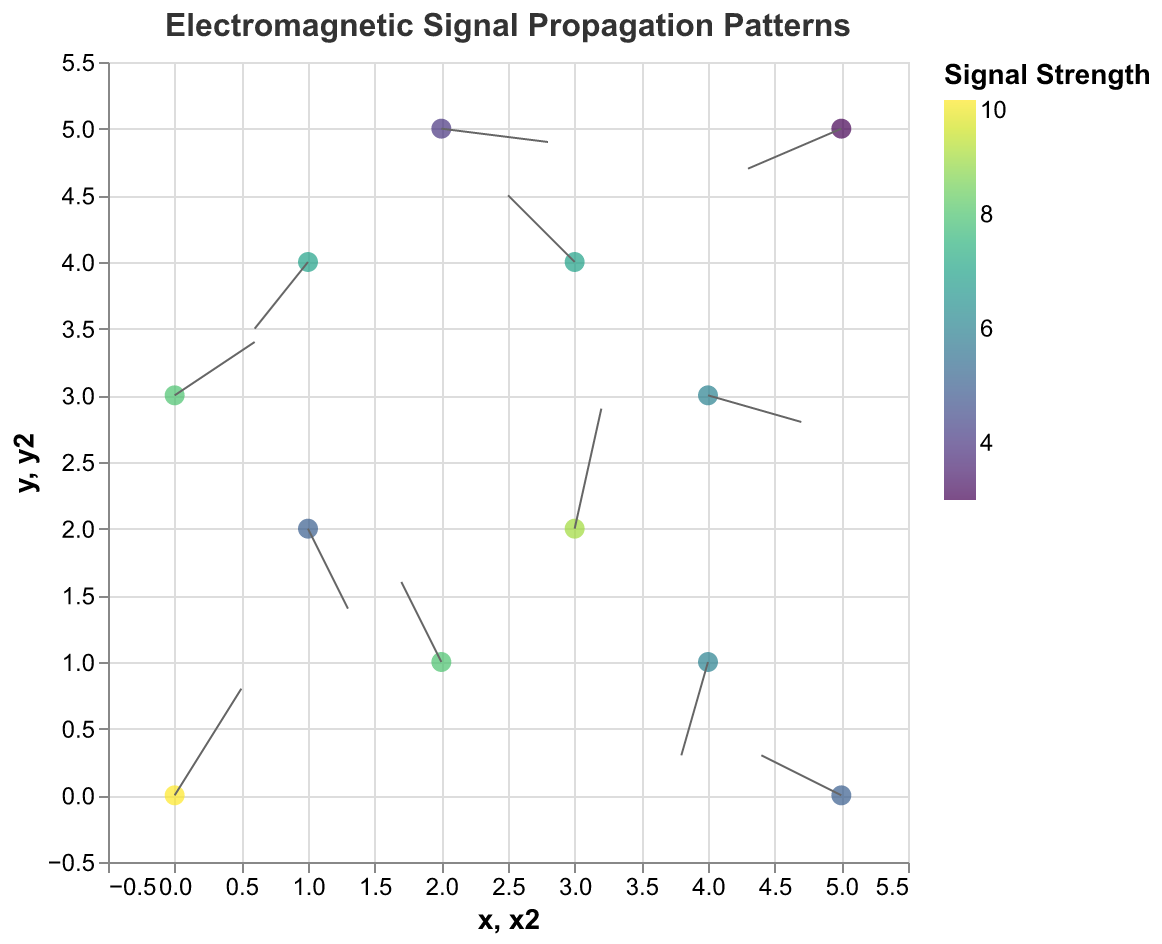What is the title of the figure? The title of the figure is usually displayed at the top and is used to summarize the main topic or purpose of the visualization. In this case, the title is clearly indicated in the JSON structure under "title" with the text "Electromagnetic Signal Propagation Patterns".
Answer: Electromagnetic Signal Propagation Patterns What are the axes ranges in the plot? The x and y axes ranges are specified in the JSON structure under the "scale" domain for both axes. For the x-axis, the range is from -0.5 to 5.5, and for the y-axis, it is the same, from -0.5 to 5.5.
Answer: -0.5 to 5.5 for both axes How many data points are represented in the plot? By counting the number of elements in the "values" array provided in the data, we can see there are 12 data points.
Answer: 12 Which data point has the highest signal strength? By referring to the "strength" field in the data and comparing their values, the data point with x: 0, y: 0 has the highest signal strength of 10.
Answer: x: 0, y: 0 Which arrows indicate a negative direction in the x-axis? Negative direction in the x-axis is indicated by negative "u" values in the data. Data points with negative "u" values are: x: 2, y: 1; x: 1, y: 4; x: 4, y: 1; x: 5, y: 0; x: 5, y: 5.
Answer: x: 2, y: 1; x: 1, y: 4; x: 4, y: 1; x: 5, y: 0; x: 5, y: 5 Which vector has the longest resulting arrow? The length of the vector can be calculated using the magnitude formula √(u² + v²). The resulting magnitudes for each vector need to be computed and compared. The vector at x: 3, y: 2 with u: 0.2, v: 0.9 has the longest resulting arrow with magnitude √(0.2² + 0.9²) = √(0.04 + 0.81) = √0.85 ≈ 0.92.
Answer: x: 3, y: 2 How does the signal strength vary with direction? To analyze the variation, we need to examine the colors representing signal strength and correlate them to arrow directions. Higher strength values are typically in yellow-green shades while lower are in blue shades. Generally, stronger signals (higher strength values) do not show a consistent trend in any specific direction.
Answer: Signal strength variation does not show a consistent directional trend Which data points have vectors pointing directly upwards? Vectors pointing directly upwards have a "u" value of 0 and a positive "v" value. After checking the data, none of the data points have a "u" of 0 and a positive "v".
Answer: None What is the average signal strength of all data points? The average signal strength can be calculated by summing the signal strengths of all data points and dividing by the number of data points. Sum = 10 + 8 + 6 + 7 + 9 + 5 + 4 + 6 + 8 + 7 + 5 + 3 = 78. The average is 78 / 12 = 6.5
Answer: 6.5 